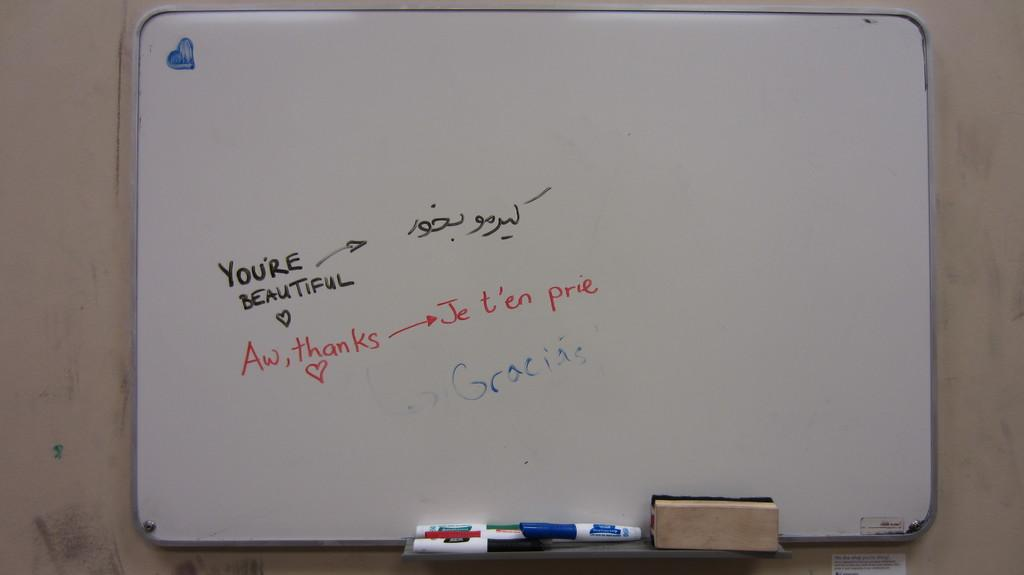<image>
Render a clear and concise summary of the photo. A whiteboard with a person saying you're beautiful and he other saying aw thanks. 